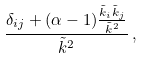<formula> <loc_0><loc_0><loc_500><loc_500>\frac { \delta _ { i j } + ( \alpha - 1 ) \frac { \tilde { k } _ { i } \tilde { k } _ { j } } { \tilde { k } ^ { 2 } } } { \tilde { k } ^ { 2 } } \, ,</formula> 